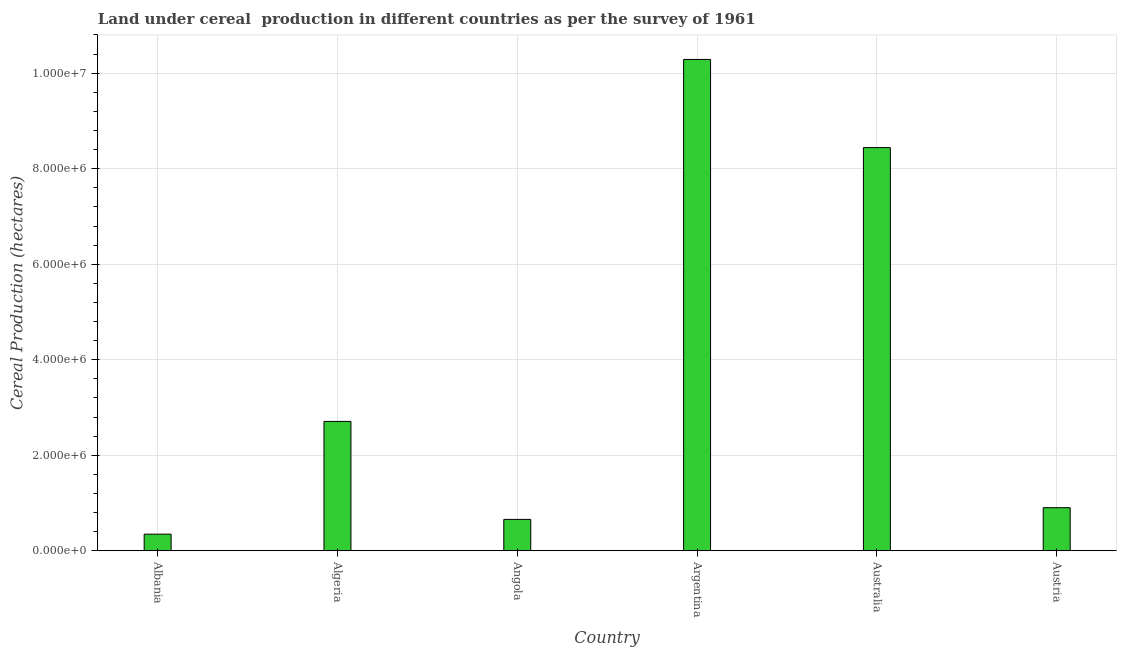Does the graph contain grids?
Your answer should be very brief. Yes. What is the title of the graph?
Offer a terse response. Land under cereal  production in different countries as per the survey of 1961. What is the label or title of the Y-axis?
Ensure brevity in your answer.  Cereal Production (hectares). What is the land under cereal production in Australia?
Offer a very short reply. 8.44e+06. Across all countries, what is the maximum land under cereal production?
Provide a succinct answer. 1.03e+07. Across all countries, what is the minimum land under cereal production?
Make the answer very short. 3.48e+05. In which country was the land under cereal production maximum?
Your response must be concise. Argentina. In which country was the land under cereal production minimum?
Your response must be concise. Albania. What is the sum of the land under cereal production?
Provide a short and direct response. 2.33e+07. What is the difference between the land under cereal production in Algeria and Angola?
Your answer should be compact. 2.05e+06. What is the average land under cereal production per country?
Provide a succinct answer. 3.89e+06. What is the median land under cereal production?
Ensure brevity in your answer.  1.81e+06. What is the ratio of the land under cereal production in Australia to that in Austria?
Your answer should be compact. 9.36. Is the land under cereal production in Angola less than that in Austria?
Offer a very short reply. Yes. Is the difference between the land under cereal production in Albania and Angola greater than the difference between any two countries?
Provide a succinct answer. No. What is the difference between the highest and the second highest land under cereal production?
Provide a succinct answer. 1.85e+06. Is the sum of the land under cereal production in Algeria and Australia greater than the maximum land under cereal production across all countries?
Provide a short and direct response. Yes. What is the difference between the highest and the lowest land under cereal production?
Provide a short and direct response. 9.94e+06. In how many countries, is the land under cereal production greater than the average land under cereal production taken over all countries?
Keep it short and to the point. 2. Are all the bars in the graph horizontal?
Offer a very short reply. No. How many countries are there in the graph?
Offer a terse response. 6. Are the values on the major ticks of Y-axis written in scientific E-notation?
Provide a succinct answer. Yes. What is the Cereal Production (hectares) of Albania?
Provide a succinct answer. 3.48e+05. What is the Cereal Production (hectares) of Algeria?
Give a very brief answer. 2.71e+06. What is the Cereal Production (hectares) of Angola?
Your answer should be very brief. 6.57e+05. What is the Cereal Production (hectares) in Argentina?
Provide a succinct answer. 1.03e+07. What is the Cereal Production (hectares) of Australia?
Your answer should be very brief. 8.44e+06. What is the Cereal Production (hectares) in Austria?
Your answer should be compact. 9.02e+05. What is the difference between the Cereal Production (hectares) in Albania and Algeria?
Ensure brevity in your answer.  -2.36e+06. What is the difference between the Cereal Production (hectares) in Albania and Angola?
Your answer should be very brief. -3.09e+05. What is the difference between the Cereal Production (hectares) in Albania and Argentina?
Make the answer very short. -9.94e+06. What is the difference between the Cereal Production (hectares) in Albania and Australia?
Ensure brevity in your answer.  -8.09e+06. What is the difference between the Cereal Production (hectares) in Albania and Austria?
Offer a very short reply. -5.54e+05. What is the difference between the Cereal Production (hectares) in Algeria and Angola?
Provide a succinct answer. 2.05e+06. What is the difference between the Cereal Production (hectares) in Algeria and Argentina?
Keep it short and to the point. -7.58e+06. What is the difference between the Cereal Production (hectares) in Algeria and Australia?
Offer a very short reply. -5.73e+06. What is the difference between the Cereal Production (hectares) in Algeria and Austria?
Keep it short and to the point. 1.81e+06. What is the difference between the Cereal Production (hectares) in Angola and Argentina?
Offer a terse response. -9.63e+06. What is the difference between the Cereal Production (hectares) in Angola and Australia?
Make the answer very short. -7.78e+06. What is the difference between the Cereal Production (hectares) in Angola and Austria?
Give a very brief answer. -2.45e+05. What is the difference between the Cereal Production (hectares) in Argentina and Australia?
Your response must be concise. 1.85e+06. What is the difference between the Cereal Production (hectares) in Argentina and Austria?
Ensure brevity in your answer.  9.39e+06. What is the difference between the Cereal Production (hectares) in Australia and Austria?
Your response must be concise. 7.54e+06. What is the ratio of the Cereal Production (hectares) in Albania to that in Algeria?
Your answer should be compact. 0.13. What is the ratio of the Cereal Production (hectares) in Albania to that in Angola?
Offer a terse response. 0.53. What is the ratio of the Cereal Production (hectares) in Albania to that in Argentina?
Your answer should be compact. 0.03. What is the ratio of the Cereal Production (hectares) in Albania to that in Australia?
Give a very brief answer. 0.04. What is the ratio of the Cereal Production (hectares) in Albania to that in Austria?
Provide a succinct answer. 0.39. What is the ratio of the Cereal Production (hectares) in Algeria to that in Angola?
Give a very brief answer. 4.12. What is the ratio of the Cereal Production (hectares) in Algeria to that in Argentina?
Your response must be concise. 0.26. What is the ratio of the Cereal Production (hectares) in Algeria to that in Australia?
Make the answer very short. 0.32. What is the ratio of the Cereal Production (hectares) in Algeria to that in Austria?
Your answer should be compact. 3. What is the ratio of the Cereal Production (hectares) in Angola to that in Argentina?
Ensure brevity in your answer.  0.06. What is the ratio of the Cereal Production (hectares) in Angola to that in Australia?
Make the answer very short. 0.08. What is the ratio of the Cereal Production (hectares) in Angola to that in Austria?
Offer a very short reply. 0.73. What is the ratio of the Cereal Production (hectares) in Argentina to that in Australia?
Provide a short and direct response. 1.22. What is the ratio of the Cereal Production (hectares) in Argentina to that in Austria?
Your answer should be compact. 11.4. What is the ratio of the Cereal Production (hectares) in Australia to that in Austria?
Provide a short and direct response. 9.36. 